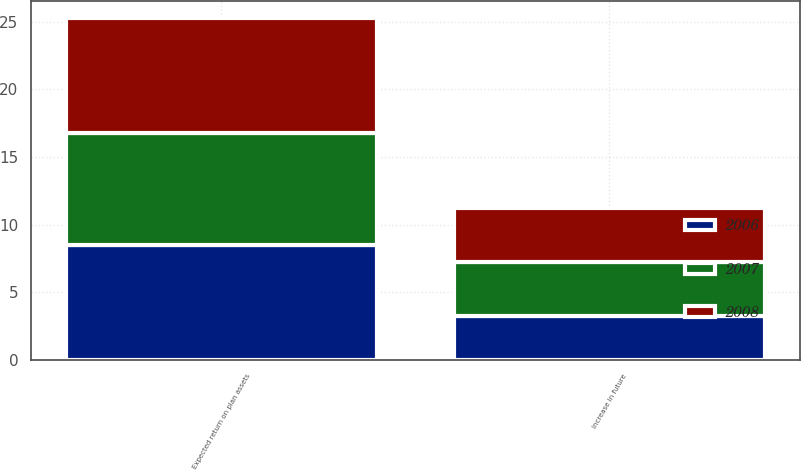Convert chart. <chart><loc_0><loc_0><loc_500><loc_500><stacked_bar_chart><ecel><fcel>Expected return on plan assets<fcel>Increase in future<nl><fcel>2007<fcel>8.25<fcel>4<nl><fcel>2008<fcel>8.5<fcel>4<nl><fcel>2006<fcel>8.5<fcel>3.25<nl></chart> 